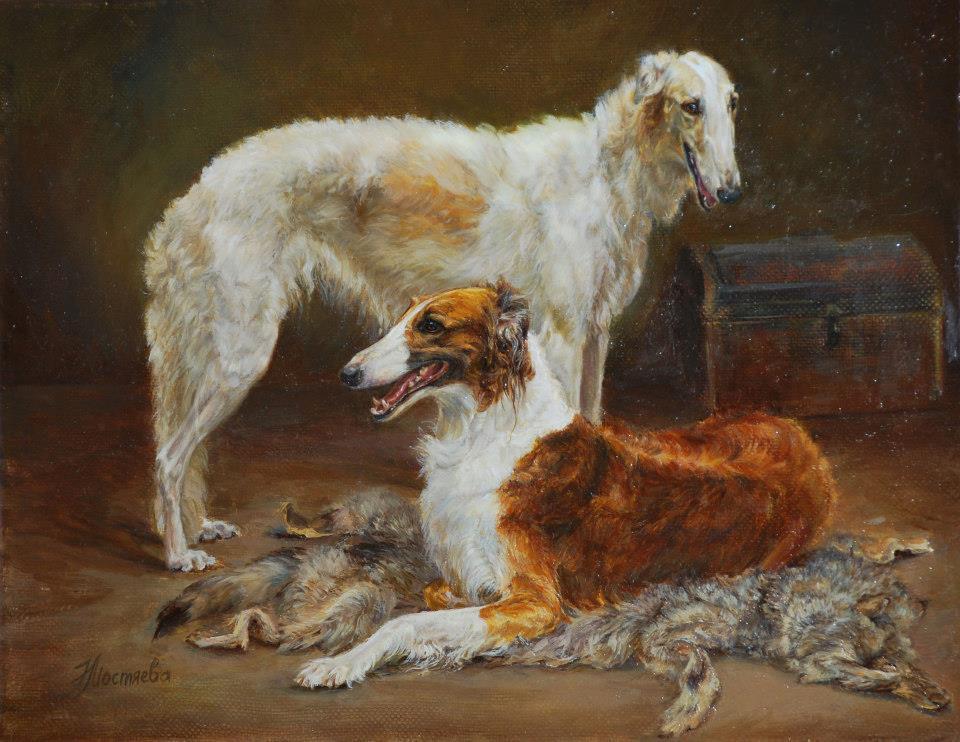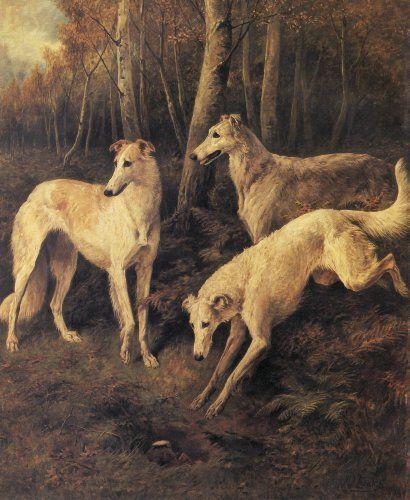The first image is the image on the left, the second image is the image on the right. Considering the images on both sides, is "Both images in the pair are paintings of dogs and not real dogs." valid? Answer yes or no. Yes. The first image is the image on the left, the second image is the image on the right. Evaluate the accuracy of this statement regarding the images: "Each image depicts multiple hounds, and the right image includes at least one hound in a bounding pose.". Is it true? Answer yes or no. Yes. 